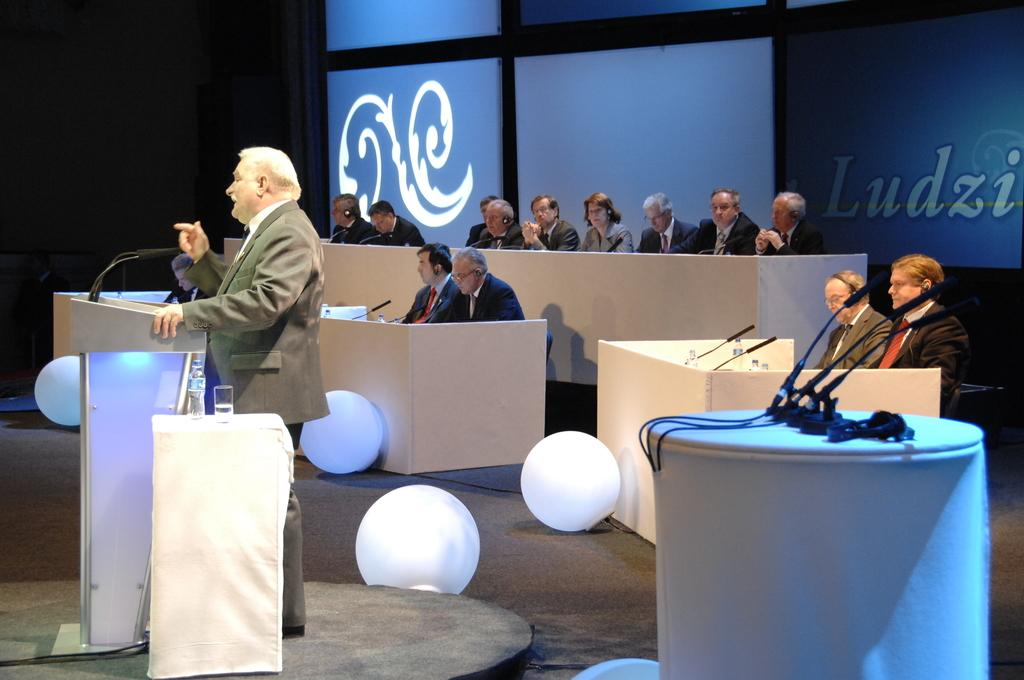What are the people in the image doing? There is a group of people sitting in chairs, suggesting they might be attending an event or gathering. What can be seen near the man in the image? There is a man standing near a podium, which might indicate that he is giving a speech or presentation. What items are on the table in the image? There is a water bottle and a glass on the table. What type of decorative objects are present in the image? There are light balls in the image. What grade does the harbor receive for its cleanliness in the image? There is no harbor present in the image, so it is not possible to evaluate its cleanliness or assign a grade. What news is being reported on the podium in the image? There is no news being reported in the image; the man standing near the podium might be giving a speech or presentation, but the content is not specified. 